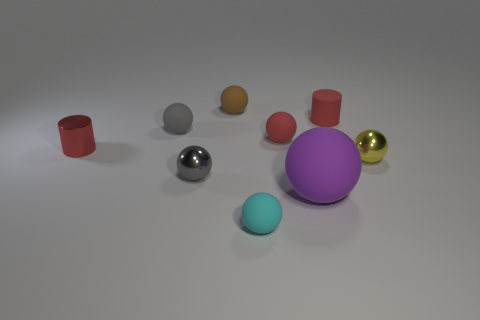Can you tell me about the lighting and the surface on which the objects are placed? The lighting in the image appears to be soft and diffused, creating gentle shadows and giving the objects a realistic appearance. The surface seems to be a matte, slightly reflective material which contributes to the subtle highlights on the objects. 